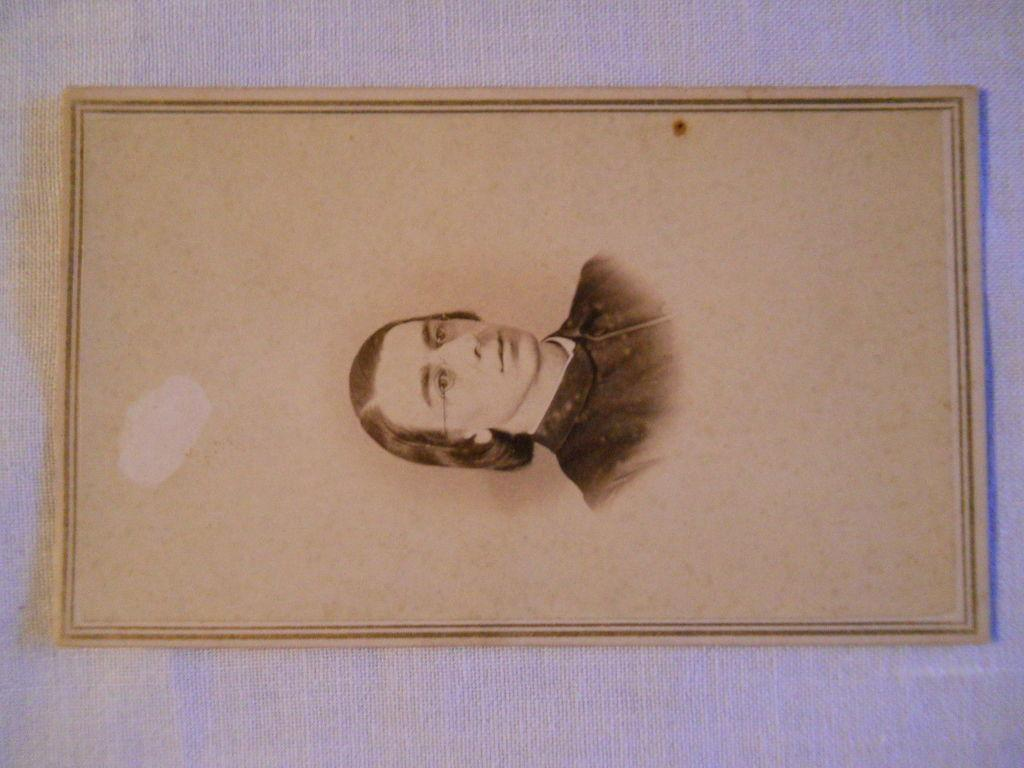What is the main subject of the image? The main subject of the image is a picture of a person. How is the picture of the person displayed in the image? The picture of the person is attached to a picture frame. What is the picture frame placed on in the image? The picture frame is placed on top of an object. What type of trail can be seen in the image? There is no trail present in the image; it features a picture of a person in a picture frame. What ideas are being expressed by the person in the picture? The image does not convey any ideas or expressions from the person in the picture, as it is a static image of a person in a picture frame. 